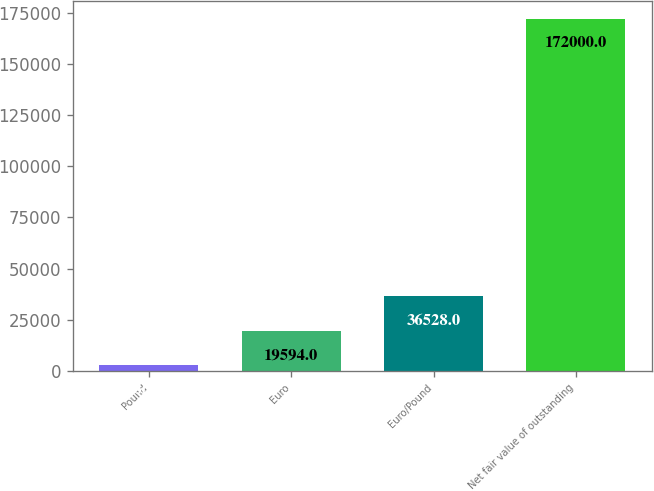<chart> <loc_0><loc_0><loc_500><loc_500><bar_chart><fcel>Pound<fcel>Euro<fcel>Euro/Pound<fcel>Net fair value of outstanding<nl><fcel>2660<fcel>19594<fcel>36528<fcel>172000<nl></chart> 